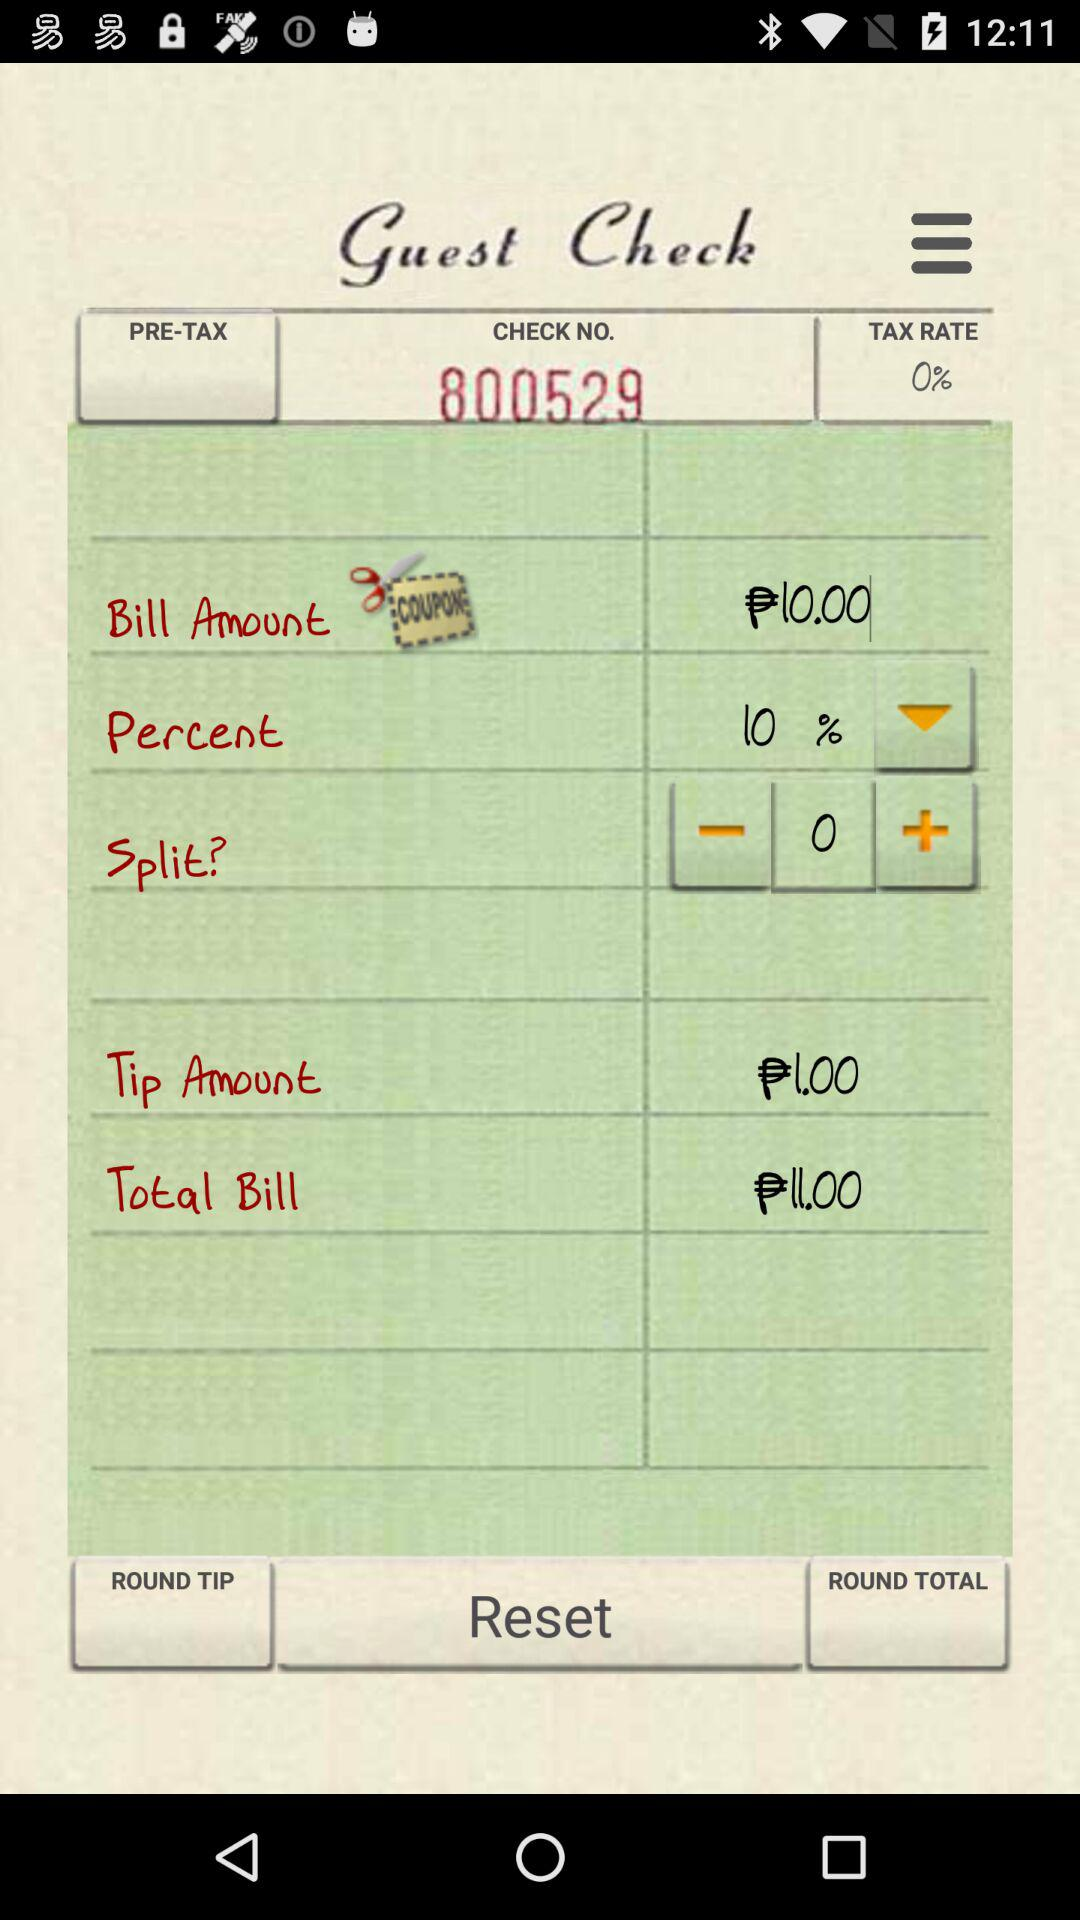What is the check number? The check number is 800529. 